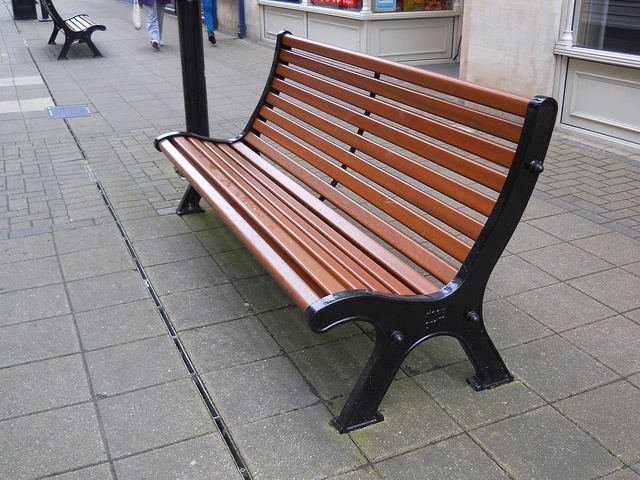Describe the objects in this image and their specific colors. I can see bench in lightgray, black, maroon, brown, and darkgray tones, bench in lightgray, black, gray, and darkgray tones, people in lightgray, gray, and darkgray tones, and people in lightgray, blue, navy, black, and gray tones in this image. 